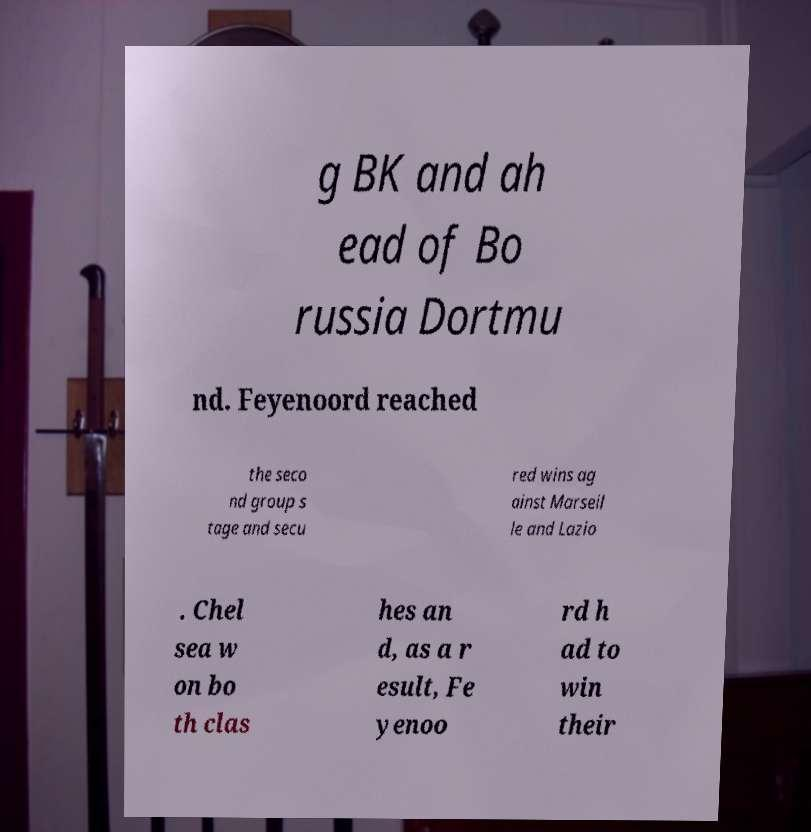Can you accurately transcribe the text from the provided image for me? g BK and ah ead of Bo russia Dortmu nd. Feyenoord reached the seco nd group s tage and secu red wins ag ainst Marseil le and Lazio . Chel sea w on bo th clas hes an d, as a r esult, Fe yenoo rd h ad to win their 